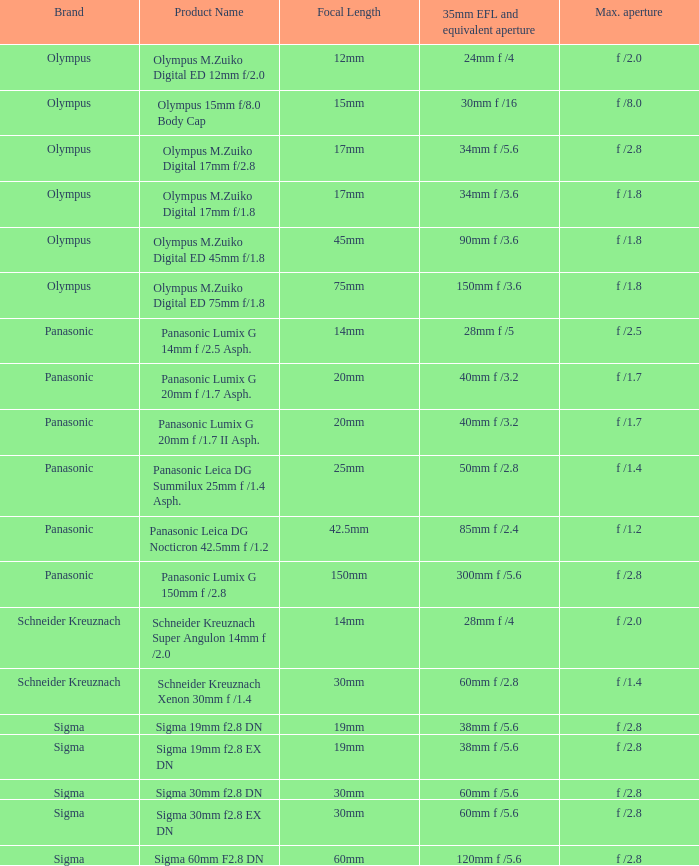5? 28mm f /5. Write the full table. {'header': ['Brand', 'Product Name', 'Focal Length', '35mm EFL and equivalent aperture', 'Max. aperture'], 'rows': [['Olympus', 'Olympus M.Zuiko Digital ED 12mm f/2.0', '12mm', '24mm f /4', 'f /2.0'], ['Olympus', 'Olympus 15mm f/8.0 Body Cap', '15mm', '30mm f /16', 'f /8.0'], ['Olympus', 'Olympus M.Zuiko Digital 17mm f/2.8', '17mm', '34mm f /5.6', 'f /2.8'], ['Olympus', 'Olympus M.Zuiko Digital 17mm f/1.8', '17mm', '34mm f /3.6', 'f /1.8'], ['Olympus', 'Olympus M.Zuiko Digital ED 45mm f/1.8', '45mm', '90mm f /3.6', 'f /1.8'], ['Olympus', 'Olympus M.Zuiko Digital ED 75mm f/1.8', '75mm', '150mm f /3.6', 'f /1.8'], ['Panasonic', 'Panasonic Lumix G 14mm f /2.5 Asph.', '14mm', '28mm f /5', 'f /2.5'], ['Panasonic', 'Panasonic Lumix G 20mm f /1.7 Asph.', '20mm', '40mm f /3.2', 'f /1.7'], ['Panasonic', 'Panasonic Lumix G 20mm f /1.7 II Asph.', '20mm', '40mm f /3.2', 'f /1.7'], ['Panasonic', 'Panasonic Leica DG Summilux 25mm f /1.4 Asph.', '25mm', '50mm f /2.8', 'f /1.4'], ['Panasonic', 'Panasonic Leica DG Nocticron 42.5mm f /1.2', '42.5mm', '85mm f /2.4', 'f /1.2'], ['Panasonic', 'Panasonic Lumix G 150mm f /2.8', '150mm', '300mm f /5.6', 'f /2.8'], ['Schneider Kreuznach', 'Schneider Kreuznach Super Angulon 14mm f /2.0', '14mm', '28mm f /4', 'f /2.0'], ['Schneider Kreuznach', 'Schneider Kreuznach Xenon 30mm f /1.4', '30mm', '60mm f /2.8', 'f /1.4'], ['Sigma', 'Sigma 19mm f2.8 DN', '19mm', '38mm f /5.6', 'f /2.8'], ['Sigma', 'Sigma 19mm f2.8 EX DN', '19mm', '38mm f /5.6', 'f /2.8'], ['Sigma', 'Sigma 30mm f2.8 DN', '30mm', '60mm f /5.6', 'f /2.8'], ['Sigma', 'Sigma 30mm f2.8 EX DN', '30mm', '60mm f /5.6', 'f /2.8'], ['Sigma', 'Sigma 60mm F2.8 DN', '60mm', '120mm f /5.6', 'f /2.8']]} 